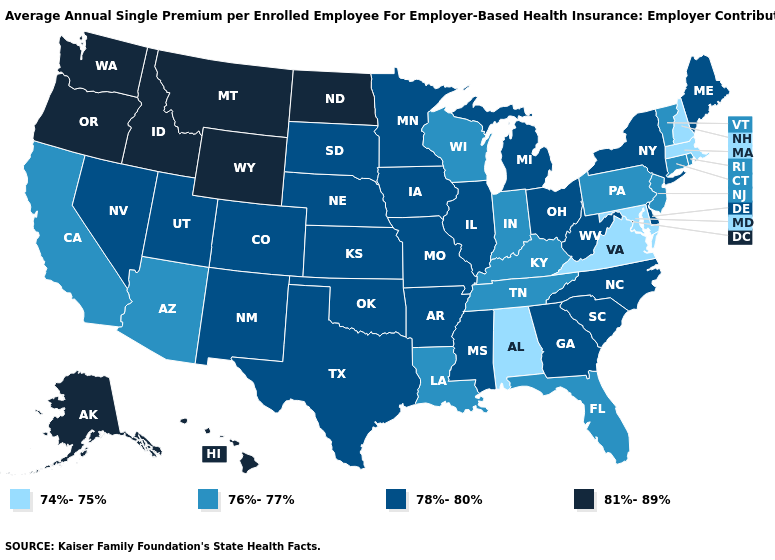Among the states that border Mississippi , which have the highest value?
Be succinct. Arkansas. How many symbols are there in the legend?
Give a very brief answer. 4. What is the lowest value in the Northeast?
Give a very brief answer. 74%-75%. Is the legend a continuous bar?
Quick response, please. No. Name the states that have a value in the range 76%-77%?
Keep it brief. Arizona, California, Connecticut, Florida, Indiana, Kentucky, Louisiana, New Jersey, Pennsylvania, Rhode Island, Tennessee, Vermont, Wisconsin. Which states have the lowest value in the West?
Answer briefly. Arizona, California. Which states have the highest value in the USA?
Answer briefly. Alaska, Hawaii, Idaho, Montana, North Dakota, Oregon, Washington, Wyoming. How many symbols are there in the legend?
Give a very brief answer. 4. What is the value of South Carolina?
Write a very short answer. 78%-80%. Which states have the lowest value in the Northeast?
Be succinct. Massachusetts, New Hampshire. Does Utah have the highest value in the West?
Quick response, please. No. Among the states that border Indiana , which have the highest value?
Short answer required. Illinois, Michigan, Ohio. Name the states that have a value in the range 76%-77%?
Quick response, please. Arizona, California, Connecticut, Florida, Indiana, Kentucky, Louisiana, New Jersey, Pennsylvania, Rhode Island, Tennessee, Vermont, Wisconsin. Does Idaho have the same value as New York?
Concise answer only. No. Does the first symbol in the legend represent the smallest category?
Keep it brief. Yes. 